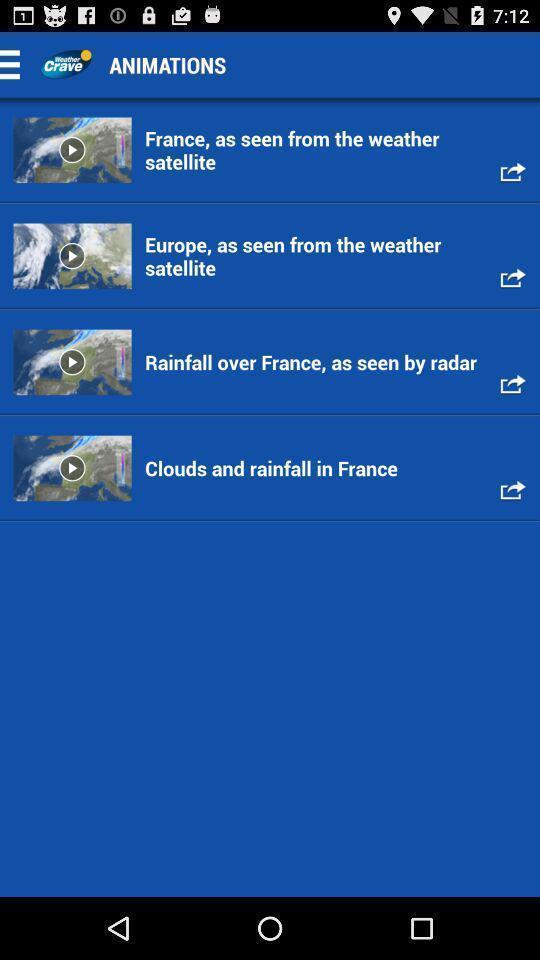Provide a textual representation of this image. Multiple animation videos are displaying. 